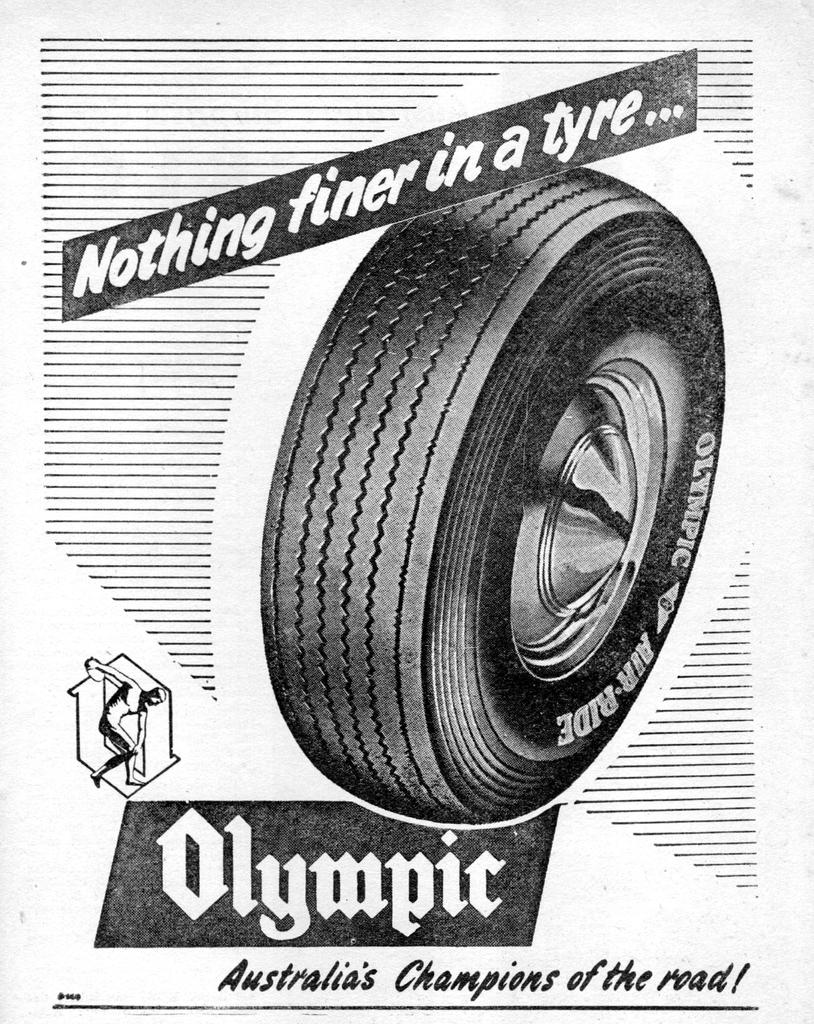What is featured in the image? There is a poster in the image. What is the subject of the poster? The poster is about a tire. Can you describe the main image on the poster? There is a tire in the middle of the poster. What else can be seen on the poster besides the tire? There is text on either side of the tire on the poster. What type of band is playing in the background of the poster? There is no band present in the image or on the poster. Can you tell me how many sinks are visible on the poster? There are no sinks visible on the poster; it features a tire and text. 